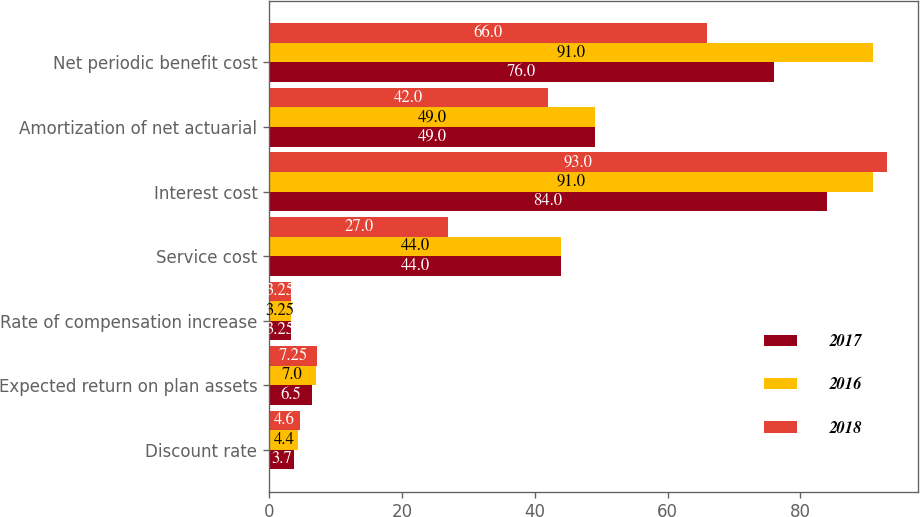<chart> <loc_0><loc_0><loc_500><loc_500><stacked_bar_chart><ecel><fcel>Discount rate<fcel>Expected return on plan assets<fcel>Rate of compensation increase<fcel>Service cost<fcel>Interest cost<fcel>Amortization of net actuarial<fcel>Net periodic benefit cost<nl><fcel>2017<fcel>3.7<fcel>6.5<fcel>3.25<fcel>44<fcel>84<fcel>49<fcel>76<nl><fcel>2016<fcel>4.4<fcel>7<fcel>3.25<fcel>44<fcel>91<fcel>49<fcel>91<nl><fcel>2018<fcel>4.6<fcel>7.25<fcel>3.25<fcel>27<fcel>93<fcel>42<fcel>66<nl></chart> 